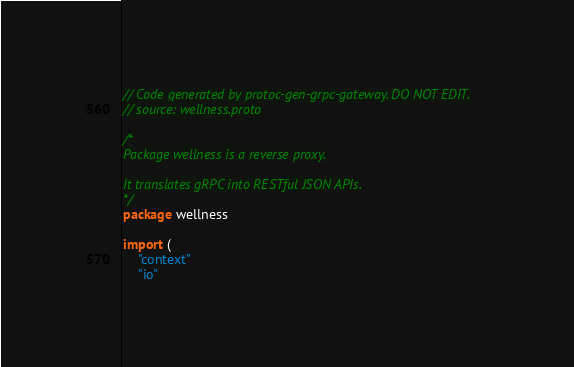<code> <loc_0><loc_0><loc_500><loc_500><_Go_>// Code generated by protoc-gen-grpc-gateway. DO NOT EDIT.
// source: wellness.proto

/*
Package wellness is a reverse proxy.

It translates gRPC into RESTful JSON APIs.
*/
package wellness

import (
	"context"
	"io"</code> 